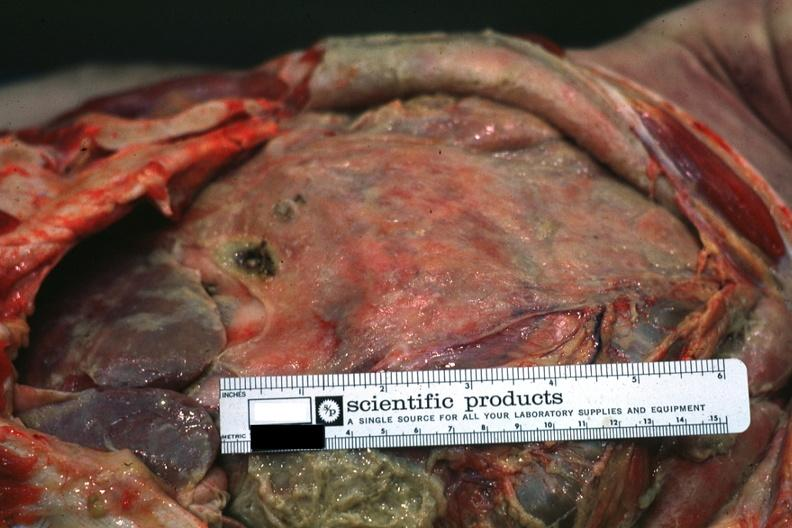where is this area in the body?
Answer the question using a single word or phrase. Abdomen 